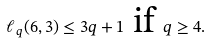<formula> <loc_0><loc_0><loc_500><loc_500>\ell _ { q } ( 6 , 3 ) \leq 3 q + 1 \text { if } q \geq 4 .</formula> 